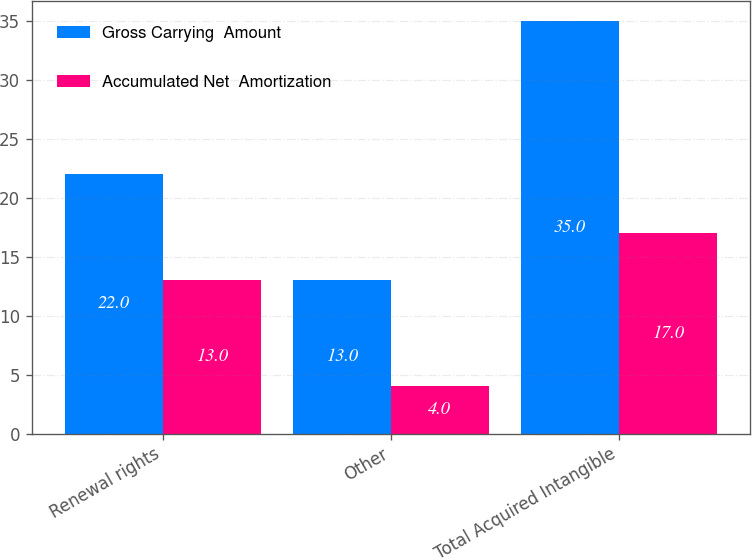Convert chart. <chart><loc_0><loc_0><loc_500><loc_500><stacked_bar_chart><ecel><fcel>Renewal rights<fcel>Other<fcel>Total Acquired Intangible<nl><fcel>Gross Carrying  Amount<fcel>22<fcel>13<fcel>35<nl><fcel>Accumulated Net  Amortization<fcel>13<fcel>4<fcel>17<nl></chart> 